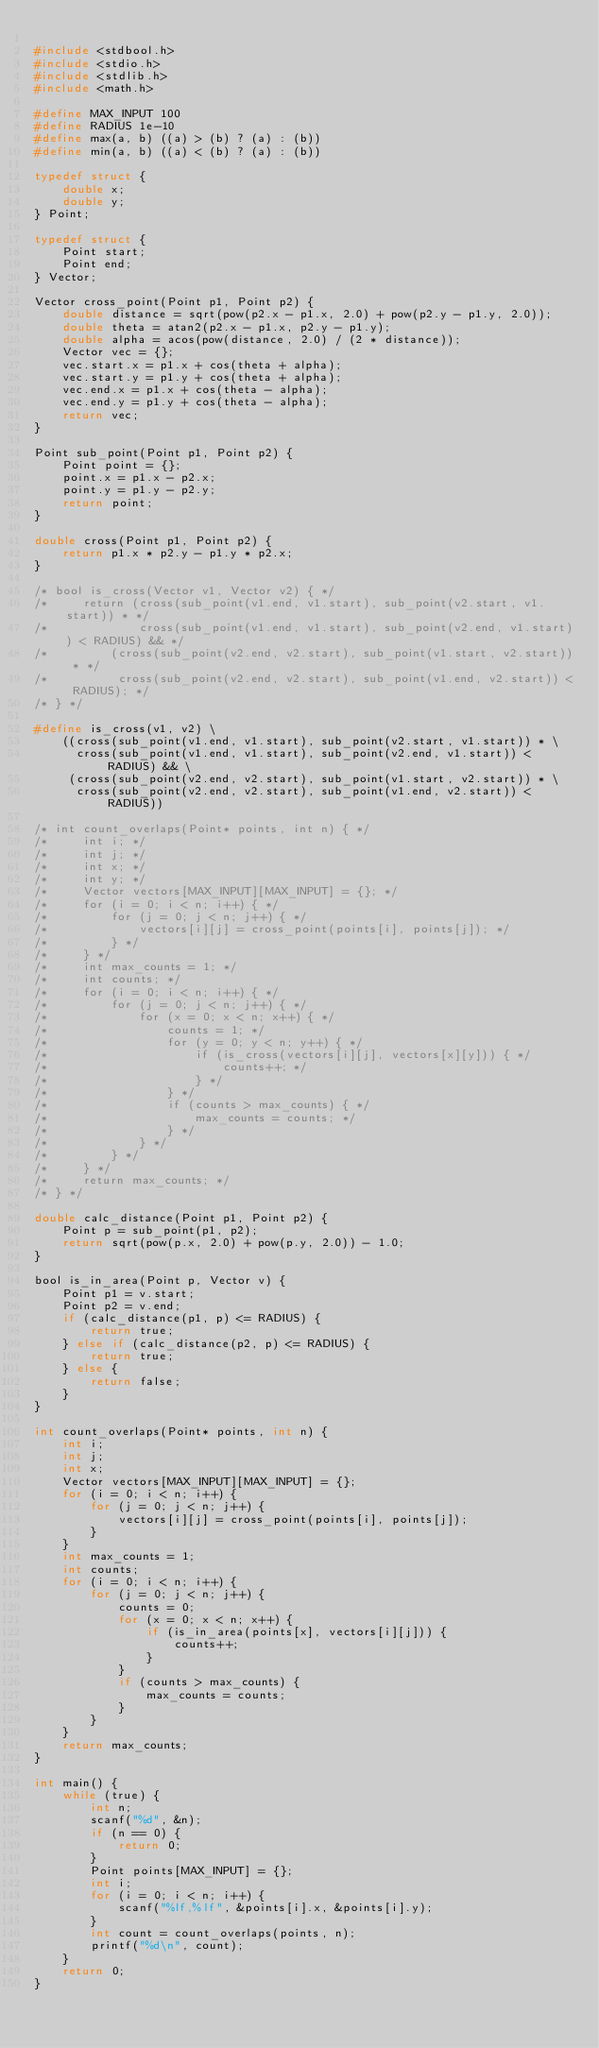Convert code to text. <code><loc_0><loc_0><loc_500><loc_500><_C_>
#include <stdbool.h>
#include <stdio.h>
#include <stdlib.h>
#include <math.h>

#define MAX_INPUT 100
#define RADIUS 1e-10
#define max(a, b) ((a) > (b) ? (a) : (b))
#define min(a, b) ((a) < (b) ? (a) : (b))

typedef struct {
    double x;
    double y;
} Point;

typedef struct {
    Point start;
    Point end;
} Vector;

Vector cross_point(Point p1, Point p2) {
    double distance = sqrt(pow(p2.x - p1.x, 2.0) + pow(p2.y - p1.y, 2.0));
    double theta = atan2(p2.x - p1.x, p2.y - p1.y);
    double alpha = acos(pow(distance, 2.0) / (2 * distance));
    Vector vec = {};
    vec.start.x = p1.x + cos(theta + alpha);
    vec.start.y = p1.y + cos(theta + alpha);
    vec.end.x = p1.x + cos(theta - alpha);
    vec.end.y = p1.y + cos(theta - alpha);
    return vec;
}

Point sub_point(Point p1, Point p2) {
    Point point = {};
    point.x = p1.x - p2.x;
    point.y = p1.y - p2.y;
    return point;
}

double cross(Point p1, Point p2) {
    return p1.x * p2.y - p1.y * p2.x;
}

/* bool is_cross(Vector v1, Vector v2) { */
/*     return (cross(sub_point(v1.end, v1.start), sub_point(v2.start, v1.start)) * */
/*             cross(sub_point(v1.end, v1.start), sub_point(v2.end, v1.start)) < RADIUS) && */
/*         (cross(sub_point(v2.end, v2.start), sub_point(v1.start, v2.start)) * */
/*          cross(sub_point(v2.end, v2.start), sub_point(v1.end, v2.start)) < RADIUS); */
/* } */

#define is_cross(v1, v2) \
    ((cross(sub_point(v1.end, v1.start), sub_point(v2.start, v1.start)) * \
      cross(sub_point(v1.end, v1.start), sub_point(v2.end, v1.start)) < RADIUS) && \
     (cross(sub_point(v2.end, v2.start), sub_point(v1.start, v2.start)) * \
      cross(sub_point(v2.end, v2.start), sub_point(v1.end, v2.start)) < RADIUS))

/* int count_overlaps(Point* points, int n) { */
/*     int i; */
/*     int j; */
/*     int x; */
/*     int y; */
/*     Vector vectors[MAX_INPUT][MAX_INPUT] = {}; */
/*     for (i = 0; i < n; i++) { */
/*         for (j = 0; j < n; j++) { */
/*             vectors[i][j] = cross_point(points[i], points[j]); */
/*         } */
/*     } */
/*     int max_counts = 1; */
/*     int counts; */
/*     for (i = 0; i < n; i++) { */
/*         for (j = 0; j < n; j++) { */
/*             for (x = 0; x < n; x++) { */
/*                 counts = 1; */
/*                 for (y = 0; y < n; y++) { */
/*                     if (is_cross(vectors[i][j], vectors[x][y])) { */
/*                         counts++; */
/*                     } */
/*                 } */
/*                 if (counts > max_counts) { */
/*                     max_counts = counts; */
/*                 } */
/*             } */
/*         } */
/*     } */
/*     return max_counts; */
/* } */

double calc_distance(Point p1, Point p2) {
    Point p = sub_point(p1, p2);
    return sqrt(pow(p.x, 2.0) + pow(p.y, 2.0)) - 1.0;
}

bool is_in_area(Point p, Vector v) {
    Point p1 = v.start;
    Point p2 = v.end;
    if (calc_distance(p1, p) <= RADIUS) {
        return true;
    } else if (calc_distance(p2, p) <= RADIUS) {
        return true;
    } else {
        return false;
    }
}

int count_overlaps(Point* points, int n) {
    int i;
    int j;
    int x;
    Vector vectors[MAX_INPUT][MAX_INPUT] = {};
    for (i = 0; i < n; i++) {
        for (j = 0; j < n; j++) {
            vectors[i][j] = cross_point(points[i], points[j]);
        }
    }
    int max_counts = 1;
    int counts;
    for (i = 0; i < n; i++) {
        for (j = 0; j < n; j++) {
            counts = 0;
            for (x = 0; x < n; x++) {
                if (is_in_area(points[x], vectors[i][j])) {
                    counts++;
                }
            }
            if (counts > max_counts) {
                max_counts = counts;
            }
        }
    }
    return max_counts;
}

int main() {
    while (true) {
        int n;
        scanf("%d", &n);
        if (n == 0) {
            return 0;
        }
        Point points[MAX_INPUT] = {};
        int i;
        for (i = 0; i < n; i++) {
            scanf("%lf,%lf", &points[i].x, &points[i].y);
        }
        int count = count_overlaps(points, n);
        printf("%d\n", count);
    }
    return 0;
}</code> 